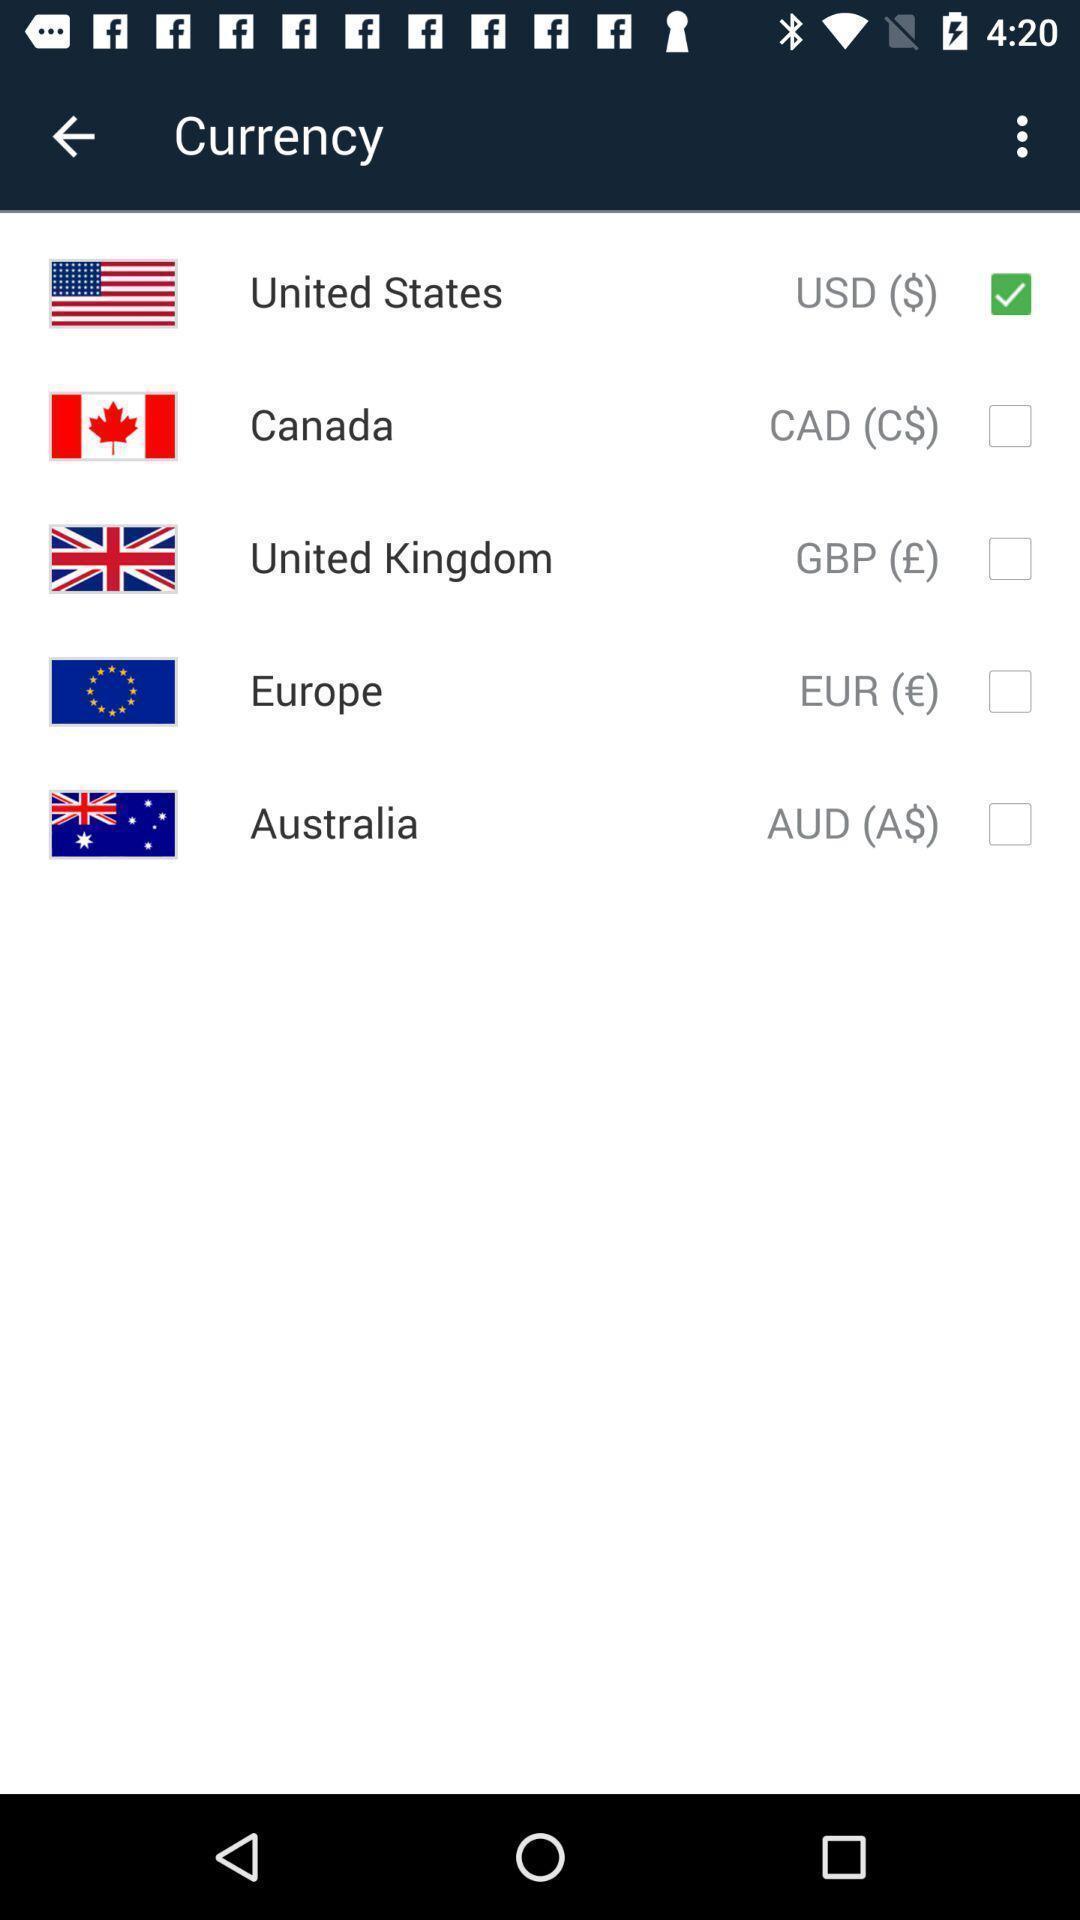Provide a textual representation of this image. Page for selecting different currencies. 